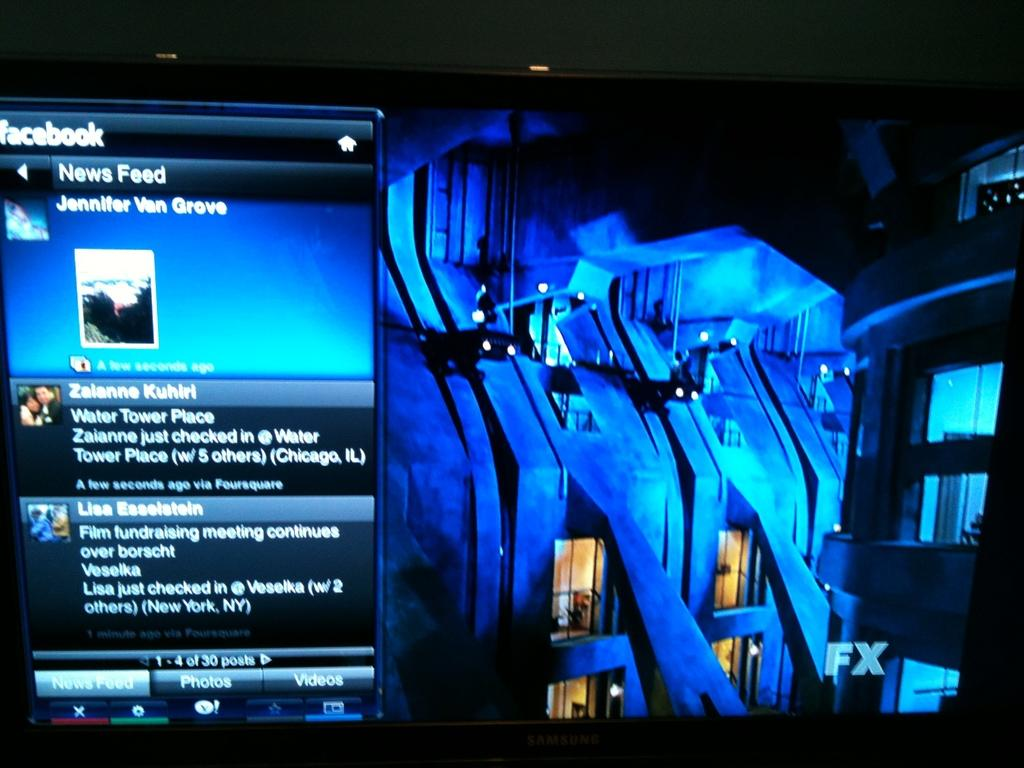Provide a one-sentence caption for the provided image. A phone that is showing a face book page with a news feed for Jennifer Van Grove. 